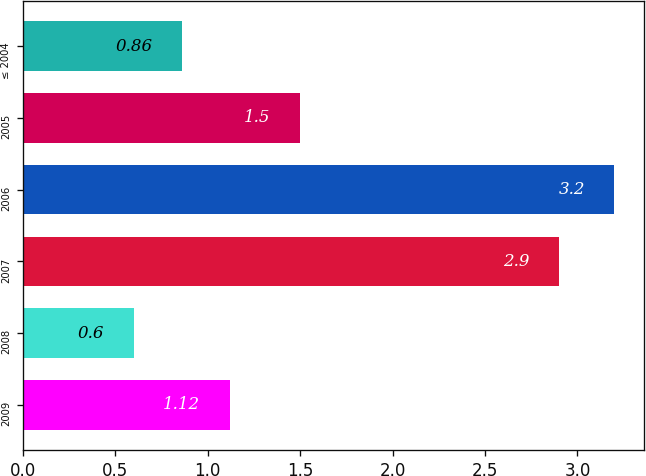<chart> <loc_0><loc_0><loc_500><loc_500><bar_chart><fcel>2009<fcel>2008<fcel>2007<fcel>2006<fcel>2005<fcel>≤ 2004<nl><fcel>1.12<fcel>0.6<fcel>2.9<fcel>3.2<fcel>1.5<fcel>0.86<nl></chart> 